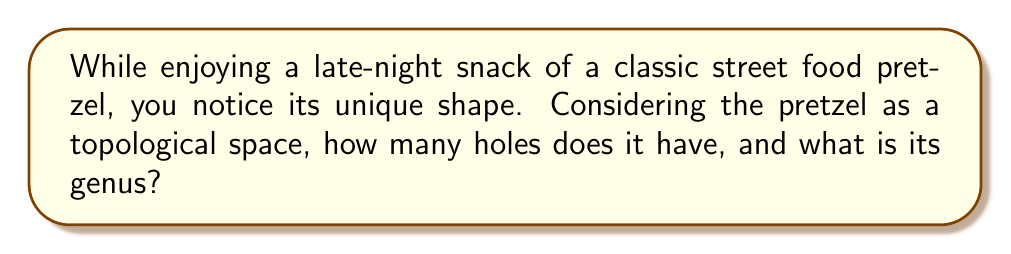Give your solution to this math problem. To analyze the topology of a pretzel-shaped food item, we need to consider its fundamental structure from a topological perspective. Let's approach this step-by-step:

1. Visualize the pretzel:
   A typical pretzel has a characteristic shape with three loops connected at a central point.

2. Topological equivalence:
   Topologically, a pretzel is equivalent to a sphere with multiple handles. Each loop of the pretzel corresponds to a handle.

3. Counting holes:
   In topology, we count the number of holes by considering how many cuts we can make without separating the object into disconnected pieces.
   - For a pretzel, we can make two cuts through the loops without disconnecting it.
   - Therefore, topologically, a pretzel has 2 holes.

4. Calculating genus:
   The genus of a surface is the maximum number of cuts along non-intersecting closed curves without rendering the resultant manifold disconnected.
   - For a pretzel, this is equivalent to the number of holes.
   - Thus, the genus of a pretzel is also 2.

5. Mathematical representation:
   In topological terms, we can express the pretzel as:

   $$ \chi = 2 - 2g $$

   Where $\chi$ is the Euler characteristic and $g$ is the genus.
   For a pretzel:
   $$ 2 - 2(2) = -2 $$

   This confirms that the pretzel has a genus of 2.

6. Betti numbers:
   The Betti numbers for a pretzel would be:
   $b_0 = 1$ (one connected component)
   $b_1 = 2$ (two independent loops)
   $b_2 = 1$ (one enclosed volume)

   This further verifies our analysis, as the alternating sum of Betti numbers equals the Euler characteristic:
   $$ \chi = b_0 - b_1 + b_2 = 1 - 2 + 1 = 0 $$

Thus, topologically, a pretzel is equivalent to a double torus, or a sphere with two handles.
Answer: A pretzel-shaped food item has 2 holes and its genus is 2. 